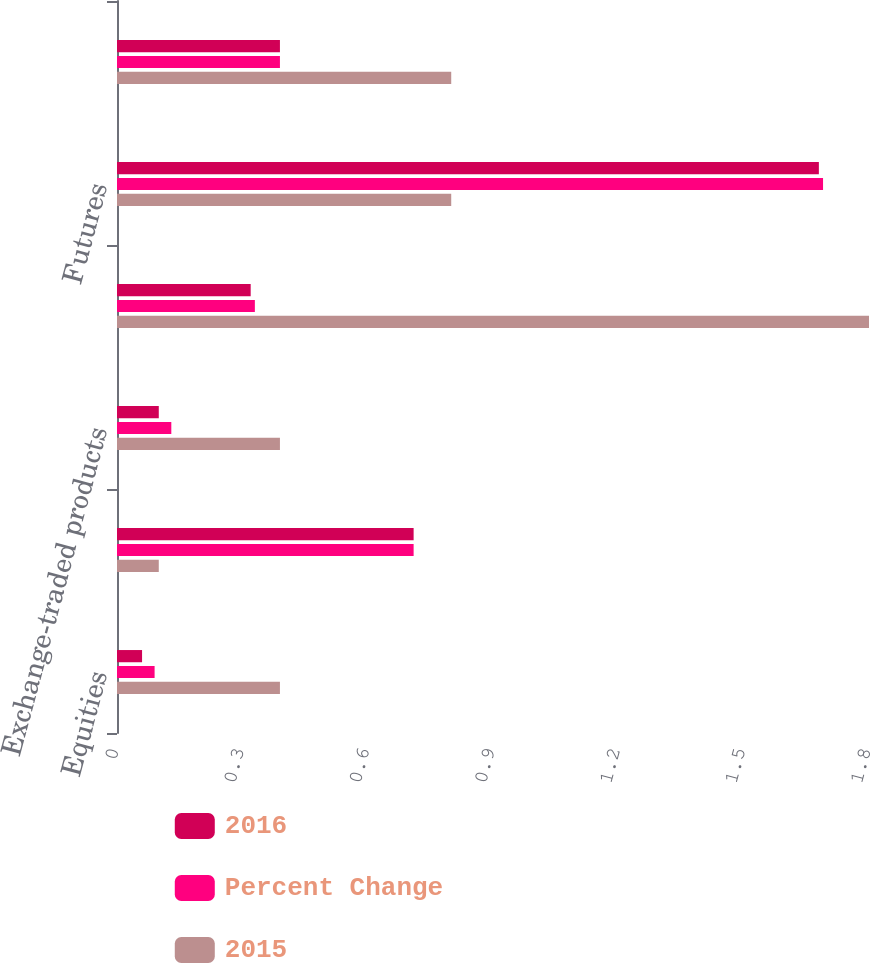Convert chart to OTSL. <chart><loc_0><loc_0><loc_500><loc_500><stacked_bar_chart><ecel><fcel>Equities<fcel>Indexes<fcel>Exchange-traded products<fcel>Total options average revenue<fcel>Futures<fcel>Total average revenue per<nl><fcel>2016<fcel>0.06<fcel>0.71<fcel>0.1<fcel>0.32<fcel>1.68<fcel>0.39<nl><fcel>Percent Change<fcel>0.09<fcel>0.71<fcel>0.13<fcel>0.33<fcel>1.69<fcel>0.39<nl><fcel>2015<fcel>0.39<fcel>0.1<fcel>0.39<fcel>1.8<fcel>0.8<fcel>0.8<nl></chart> 